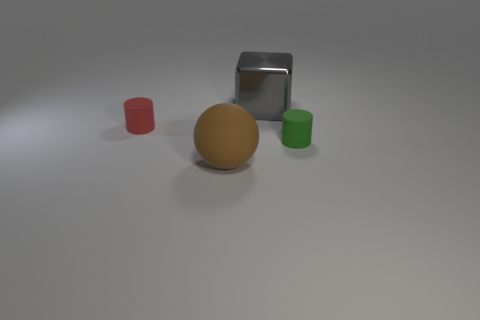Add 4 blue metal cubes. How many objects exist? 8 Subtract all cubes. How many objects are left? 3 Subtract 2 cylinders. How many cylinders are left? 0 Add 4 red matte cylinders. How many red matte cylinders exist? 5 Subtract 0 gray balls. How many objects are left? 4 Subtract all red cylinders. Subtract all brown spheres. How many cylinders are left? 1 Subtract all gray spheres. How many green cylinders are left? 1 Subtract all small rubber cylinders. Subtract all brown rubber spheres. How many objects are left? 1 Add 1 large brown matte things. How many large brown matte things are left? 2 